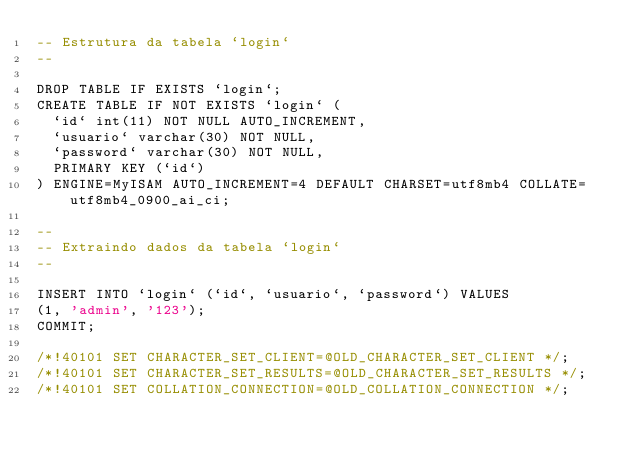Convert code to text. <code><loc_0><loc_0><loc_500><loc_500><_SQL_>-- Estrutura da tabela `login`
--

DROP TABLE IF EXISTS `login`;
CREATE TABLE IF NOT EXISTS `login` (
  `id` int(11) NOT NULL AUTO_INCREMENT,
  `usuario` varchar(30) NOT NULL,
  `password` varchar(30) NOT NULL,
  PRIMARY KEY (`id`)
) ENGINE=MyISAM AUTO_INCREMENT=4 DEFAULT CHARSET=utf8mb4 COLLATE=utf8mb4_0900_ai_ci;

--
-- Extraindo dados da tabela `login`
--

INSERT INTO `login` (`id`, `usuario`, `password`) VALUES
(1, 'admin', '123');
COMMIT;

/*!40101 SET CHARACTER_SET_CLIENT=@OLD_CHARACTER_SET_CLIENT */;
/*!40101 SET CHARACTER_SET_RESULTS=@OLD_CHARACTER_SET_RESULTS */;
/*!40101 SET COLLATION_CONNECTION=@OLD_COLLATION_CONNECTION */;
</code> 